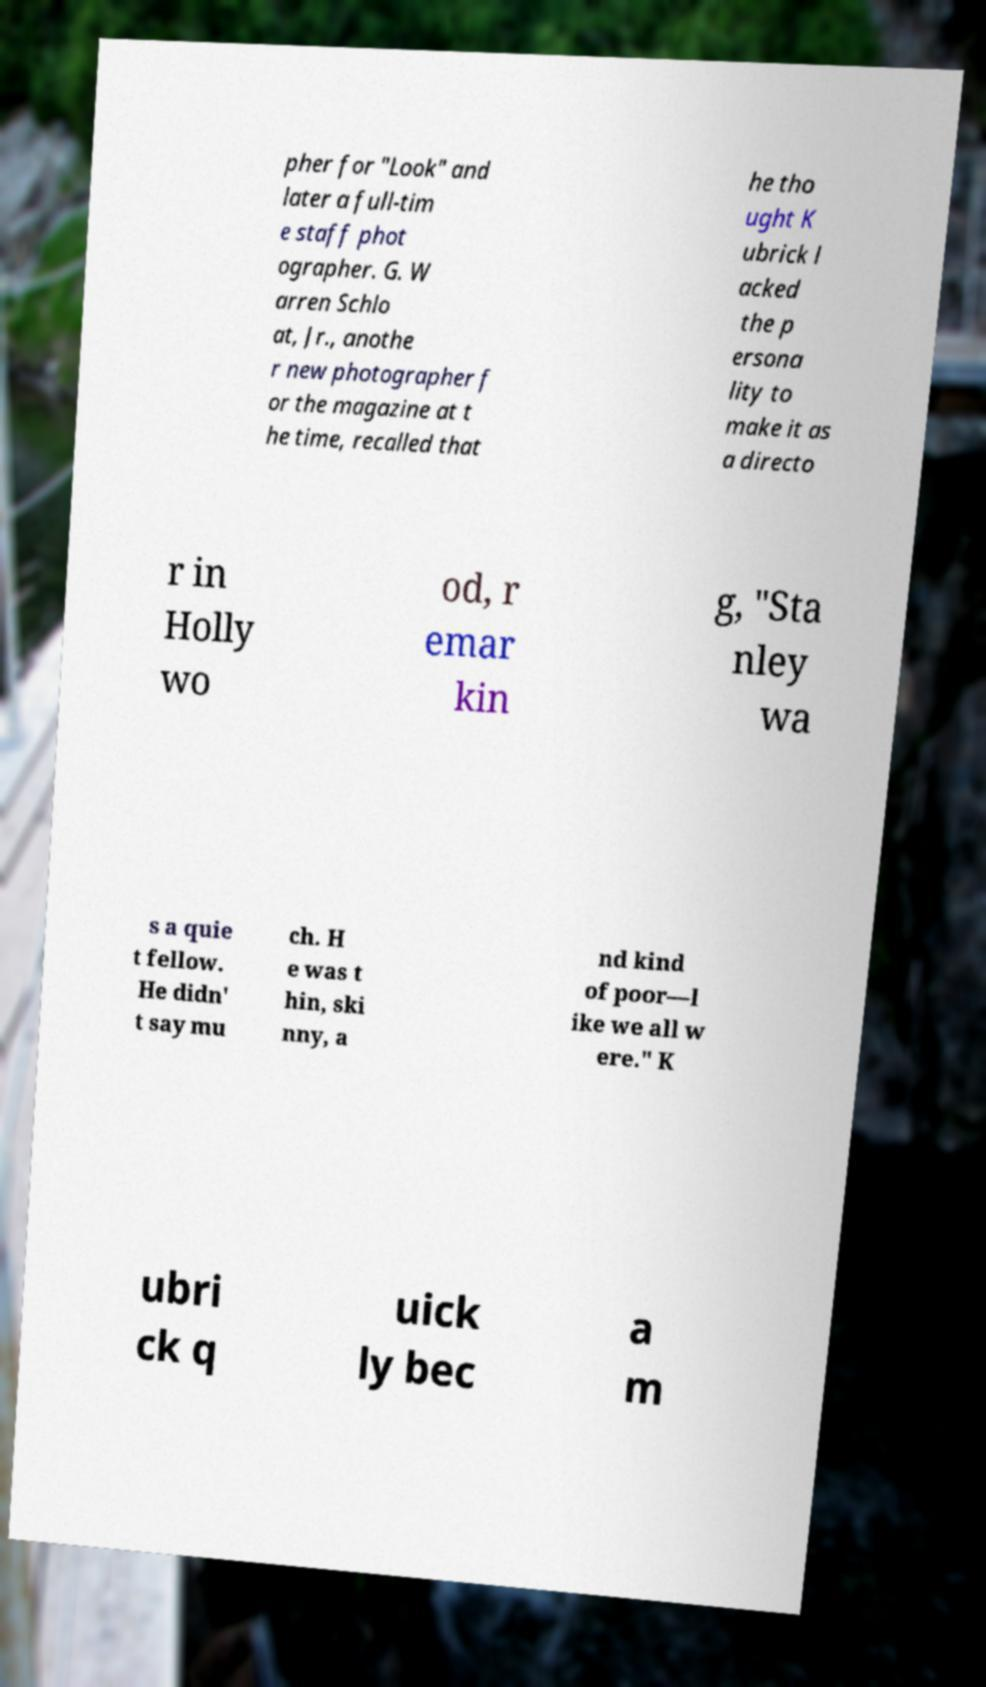Could you extract and type out the text from this image? pher for "Look" and later a full-tim e staff phot ographer. G. W arren Schlo at, Jr., anothe r new photographer f or the magazine at t he time, recalled that he tho ught K ubrick l acked the p ersona lity to make it as a directo r in Holly wo od, r emar kin g, "Sta nley wa s a quie t fellow. He didn' t say mu ch. H e was t hin, ski nny, a nd kind of poor—l ike we all w ere." K ubri ck q uick ly bec a m 